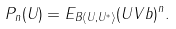<formula> <loc_0><loc_0><loc_500><loc_500>P _ { n } ( U ) = E _ { B \langle U , U ^ { * } \rangle } ( U V b ) ^ { n } .</formula> 